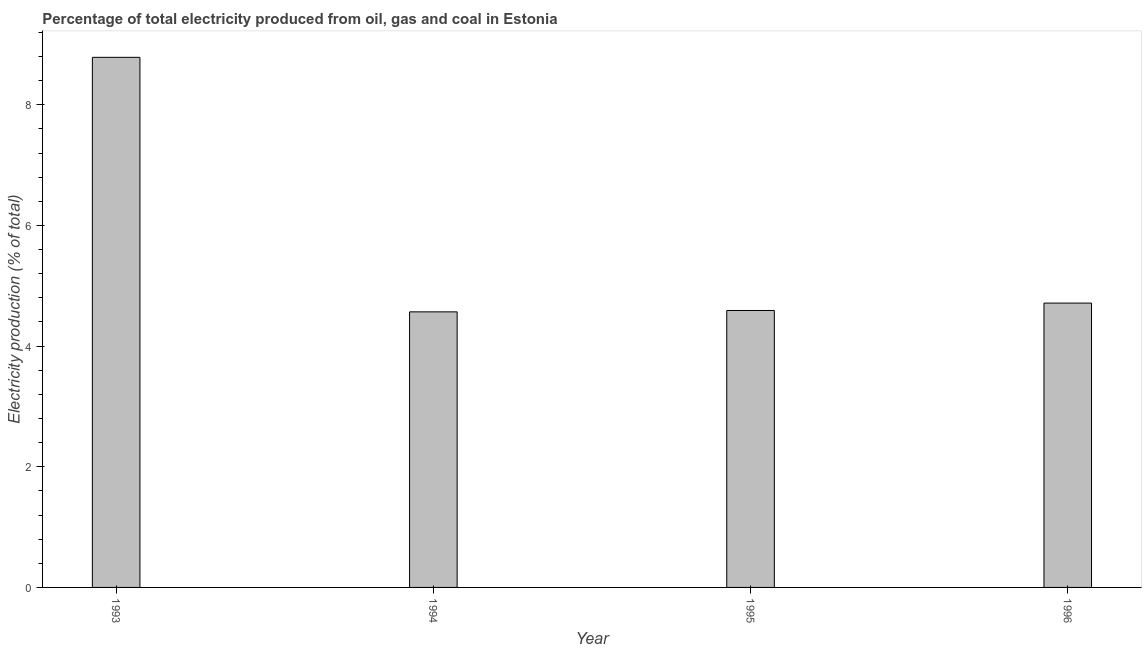Does the graph contain any zero values?
Provide a short and direct response. No. Does the graph contain grids?
Provide a succinct answer. No. What is the title of the graph?
Provide a short and direct response. Percentage of total electricity produced from oil, gas and coal in Estonia. What is the label or title of the X-axis?
Your answer should be very brief. Year. What is the label or title of the Y-axis?
Your answer should be compact. Electricity production (% of total). What is the electricity production in 1996?
Offer a terse response. 4.71. Across all years, what is the maximum electricity production?
Give a very brief answer. 8.79. Across all years, what is the minimum electricity production?
Your answer should be compact. 4.57. In which year was the electricity production minimum?
Provide a short and direct response. 1994. What is the sum of the electricity production?
Your response must be concise. 22.66. What is the difference between the electricity production in 1995 and 1996?
Provide a short and direct response. -0.12. What is the average electricity production per year?
Make the answer very short. 5.66. What is the median electricity production?
Offer a very short reply. 4.65. What is the ratio of the electricity production in 1993 to that in 1994?
Keep it short and to the point. 1.92. Is the electricity production in 1993 less than that in 1996?
Offer a terse response. No. Is the difference between the electricity production in 1993 and 1994 greater than the difference between any two years?
Your answer should be compact. Yes. What is the difference between the highest and the second highest electricity production?
Your answer should be compact. 4.07. What is the difference between the highest and the lowest electricity production?
Keep it short and to the point. 4.22. How many bars are there?
Keep it short and to the point. 4. Are all the bars in the graph horizontal?
Your answer should be compact. No. What is the difference between two consecutive major ticks on the Y-axis?
Your answer should be very brief. 2. What is the Electricity production (% of total) in 1993?
Offer a very short reply. 8.79. What is the Electricity production (% of total) in 1994?
Your answer should be compact. 4.57. What is the Electricity production (% of total) of 1995?
Your response must be concise. 4.59. What is the Electricity production (% of total) in 1996?
Make the answer very short. 4.71. What is the difference between the Electricity production (% of total) in 1993 and 1994?
Your response must be concise. 4.22. What is the difference between the Electricity production (% of total) in 1993 and 1995?
Make the answer very short. 4.2. What is the difference between the Electricity production (% of total) in 1993 and 1996?
Offer a terse response. 4.07. What is the difference between the Electricity production (% of total) in 1994 and 1995?
Your answer should be very brief. -0.02. What is the difference between the Electricity production (% of total) in 1994 and 1996?
Keep it short and to the point. -0.15. What is the difference between the Electricity production (% of total) in 1995 and 1996?
Your response must be concise. -0.12. What is the ratio of the Electricity production (% of total) in 1993 to that in 1994?
Ensure brevity in your answer.  1.92. What is the ratio of the Electricity production (% of total) in 1993 to that in 1995?
Your response must be concise. 1.91. What is the ratio of the Electricity production (% of total) in 1993 to that in 1996?
Provide a short and direct response. 1.86. What is the ratio of the Electricity production (% of total) in 1994 to that in 1995?
Your response must be concise. 0.99. What is the ratio of the Electricity production (% of total) in 1994 to that in 1996?
Offer a very short reply. 0.97. 